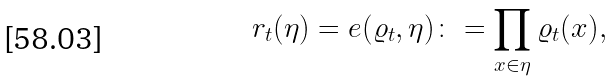Convert formula to latex. <formula><loc_0><loc_0><loc_500><loc_500>r _ { t } ( \eta ) = e ( \varrho _ { t } , \eta ) \colon = \prod _ { x \in \eta } \varrho _ { t } ( x ) ,</formula> 